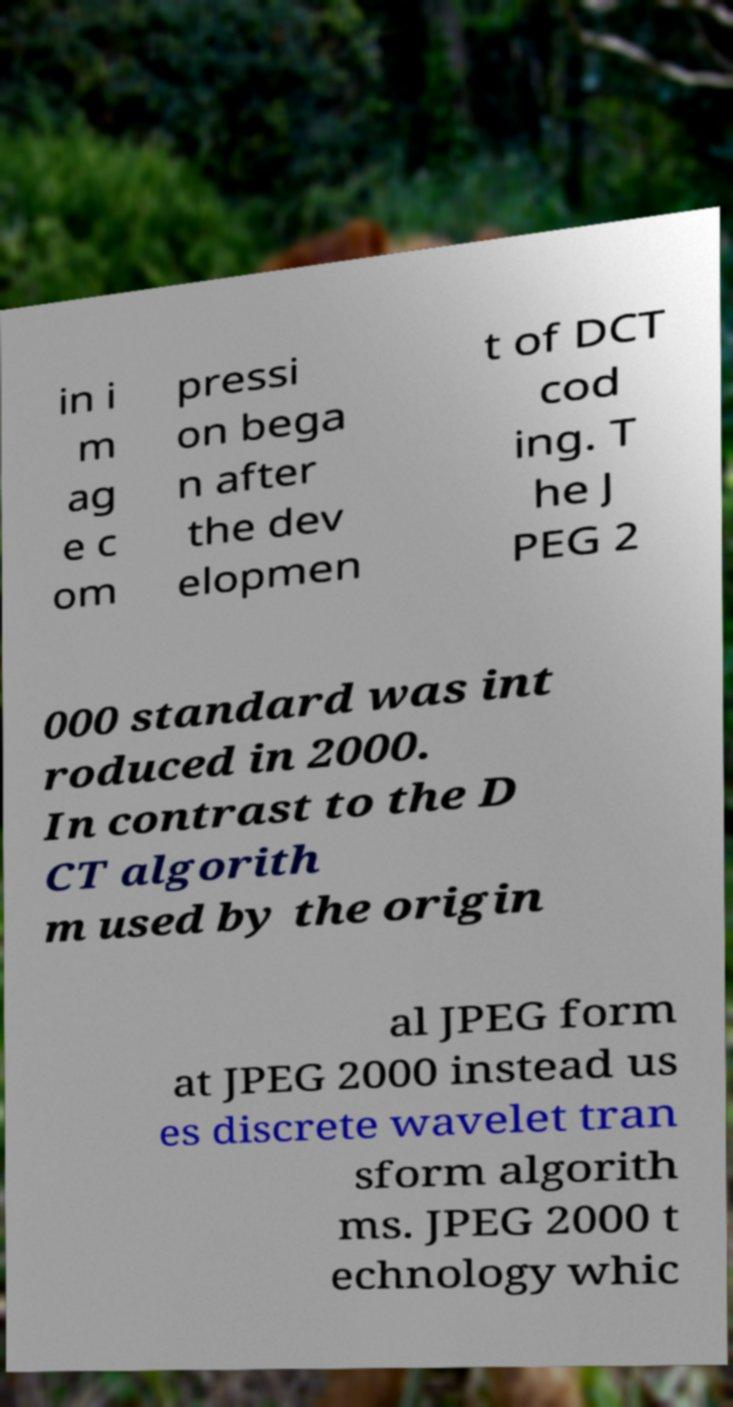Please read and relay the text visible in this image. What does it say? in i m ag e c om pressi on bega n after the dev elopmen t of DCT cod ing. T he J PEG 2 000 standard was int roduced in 2000. In contrast to the D CT algorith m used by the origin al JPEG form at JPEG 2000 instead us es discrete wavelet tran sform algorith ms. JPEG 2000 t echnology whic 